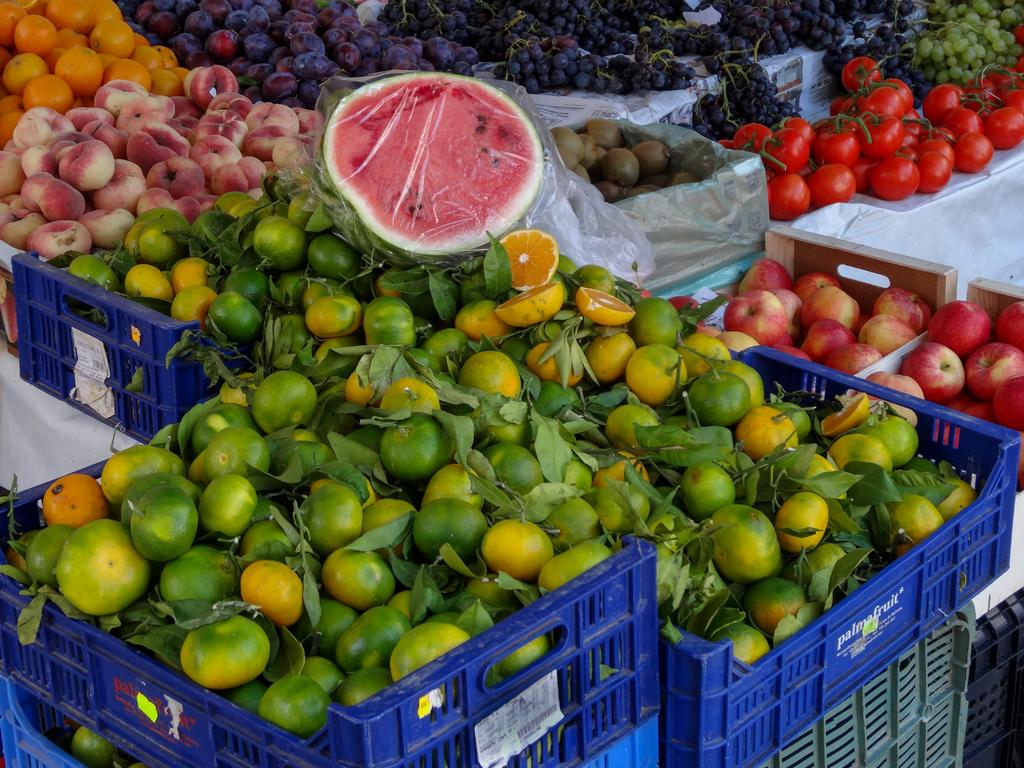What type of food can be seen in the image? There are fruits in the image. How are the fruits arranged or contained in the image? The fruits are in boxes. What type of glass is being used to hold the fruits in the image? There is no glass present in the image; the fruits are in boxes. How many eggs can be seen in the image? There are no eggs present in the image; it features fruits in boxes. 